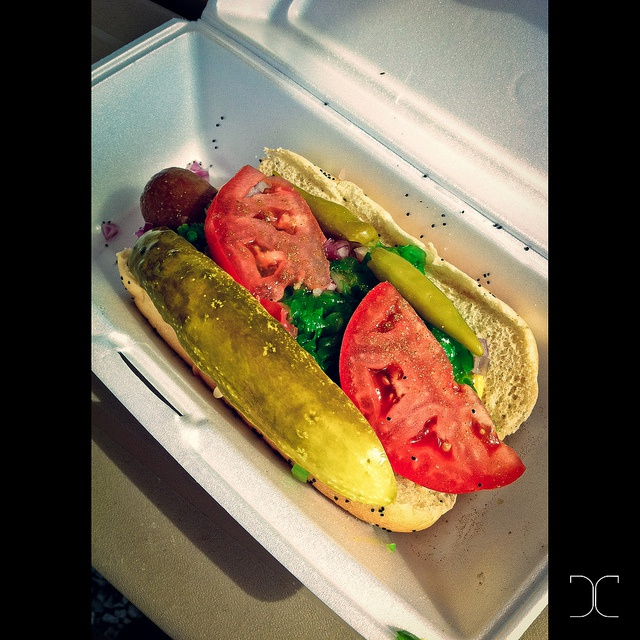Describe the objects in this image and their specific colors. I can see hot dog in black, olive, tan, and salmon tones and sandwich in black, olive, orange, and salmon tones in this image. 